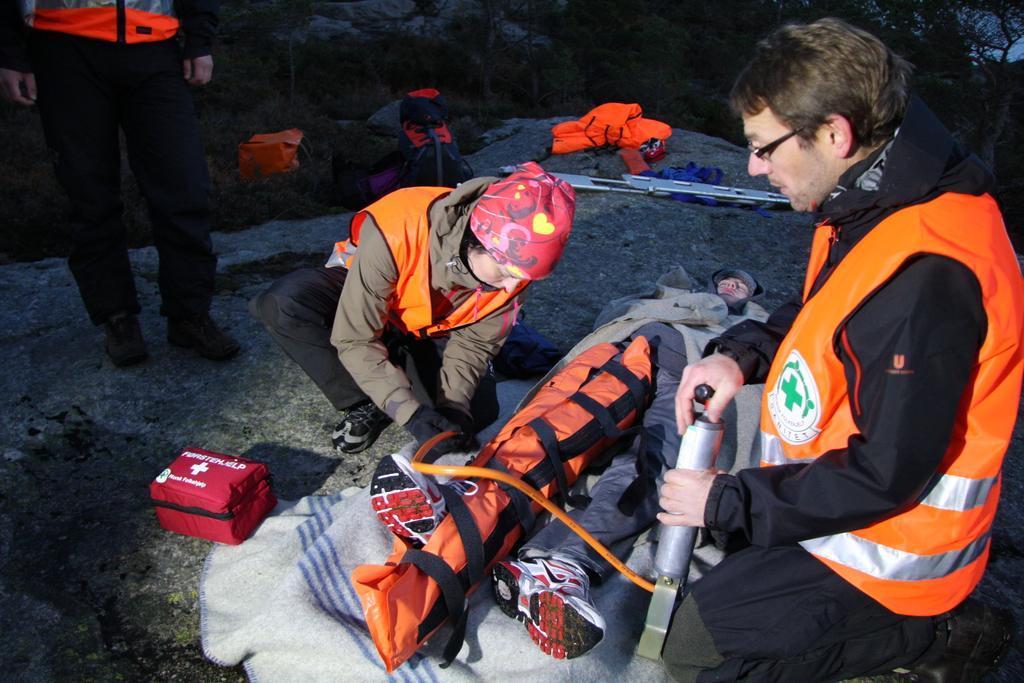How would you summarize this image in a sentence or two? In the image we can see there are people around they are wearing clothes, shoes and this person is wearing spectacles. There is a first aid box, gloves, cap, pump and there is a person lying. This is a cloth and grass. 